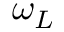<formula> <loc_0><loc_0><loc_500><loc_500>\omega _ { L }</formula> 